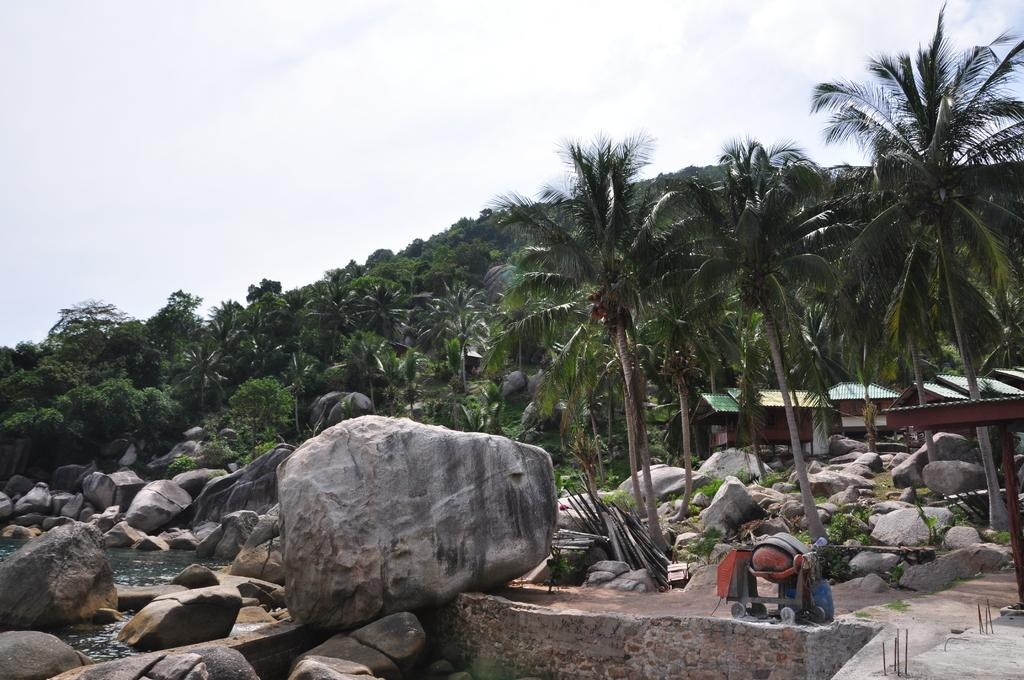What type of natural elements can be seen in the image? There are many rocks and trees in the image. What type of shelter is present in the image? There is a tent house in the image. What can be seen flowing or standing still in the image? There is water visible in the image. What else is present in the image besides the natural elements and shelter? There is an object in the image. What part of the environment is visible in the image? The sky is visible in the image. How many crows are perched on the tent house in the image? There are no crows present in the image; it only features rocks, trees, water, an object, and the tent house. What type of clothing is being washed in the image? There is no washing or clothing visible in the image. 